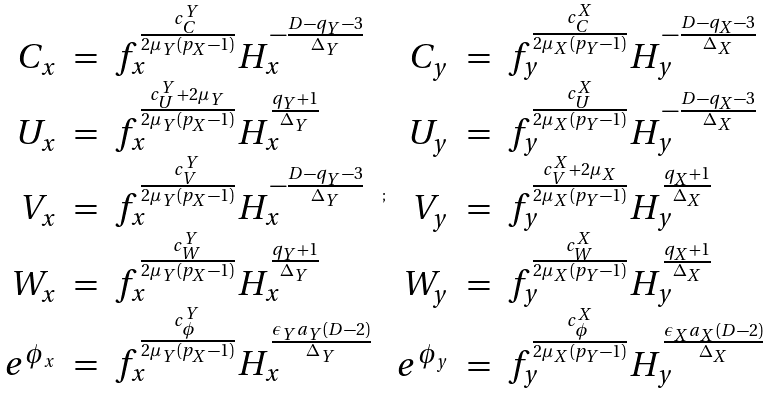<formula> <loc_0><loc_0><loc_500><loc_500>\begin{array} { r c l } C _ { x } & = & f _ { x } ^ { \frac { c ^ { Y } _ { C } } { 2 \mu _ { Y } ( p _ { X } - 1 ) } } H _ { x } ^ { - \frac { D - q _ { Y } - 3 } { \Delta _ { Y } } } \\ U _ { x } & = & f _ { x } ^ { \frac { c ^ { Y } _ { U } + 2 \mu _ { Y } } { 2 \mu _ { Y } ( p _ { X } - 1 ) } } H _ { x } ^ { \frac { q _ { Y } + 1 } { \Delta _ { Y } } } \\ V _ { x } & = & f _ { x } ^ { \frac { c ^ { Y } _ { V } } { 2 \mu _ { Y } ( p _ { X } - 1 ) } } H _ { x } ^ { - \frac { D - q _ { Y } - 3 } { \Delta _ { Y } } } \\ W _ { x } & = & f _ { x } ^ { \frac { c ^ { Y } _ { W } } { 2 \mu _ { Y } ( p _ { X } - 1 ) } } H _ { x } ^ { \frac { q _ { Y } + 1 } { \Delta _ { Y } } } \\ e ^ { \phi _ { x } } & = & f _ { x } ^ { \frac { c ^ { Y } _ { \phi } } { 2 \mu _ { Y } ( p _ { X } - 1 ) } } H _ { x } ^ { \frac { \epsilon _ { Y } a _ { Y } ( D - 2 ) } { \Delta _ { Y } } } \end{array} ; \begin{array} { r c l } C _ { y } & = & f _ { y } ^ { \frac { c ^ { X } _ { C } } { 2 \mu _ { X } ( p _ { Y } - 1 ) } } H _ { y } ^ { - \frac { D - q _ { X } - 3 } { \Delta _ { X } } } \\ U _ { y } & = & f _ { y } ^ { \frac { c ^ { X } _ { U } } { 2 \mu _ { X } ( p _ { Y } - 1 ) } } H _ { y } ^ { - \frac { D - q _ { X } - 3 } { \Delta _ { X } } } \\ V _ { y } & = & f _ { y } ^ { \frac { c ^ { X } _ { V } + 2 \mu _ { X } } { 2 \mu _ { X } ( p _ { Y } - 1 ) } } H _ { y } ^ { \frac { q _ { X } + 1 } { \Delta _ { X } } } \\ W _ { y } & = & f _ { y } ^ { \frac { c ^ { X } _ { W } } { 2 \mu _ { X } ( p _ { Y } - 1 ) } } H _ { y } ^ { \frac { q _ { X } + 1 } { \Delta _ { X } } } \\ e ^ { \phi _ { y } } & = & f _ { y } ^ { \frac { c ^ { X } _ { \phi } } { 2 \mu _ { X } ( p _ { Y } - 1 ) } } H _ { y } ^ { \frac { \epsilon _ { X } a _ { X } ( D - 2 ) } { \Delta _ { X } } } \end{array}</formula> 